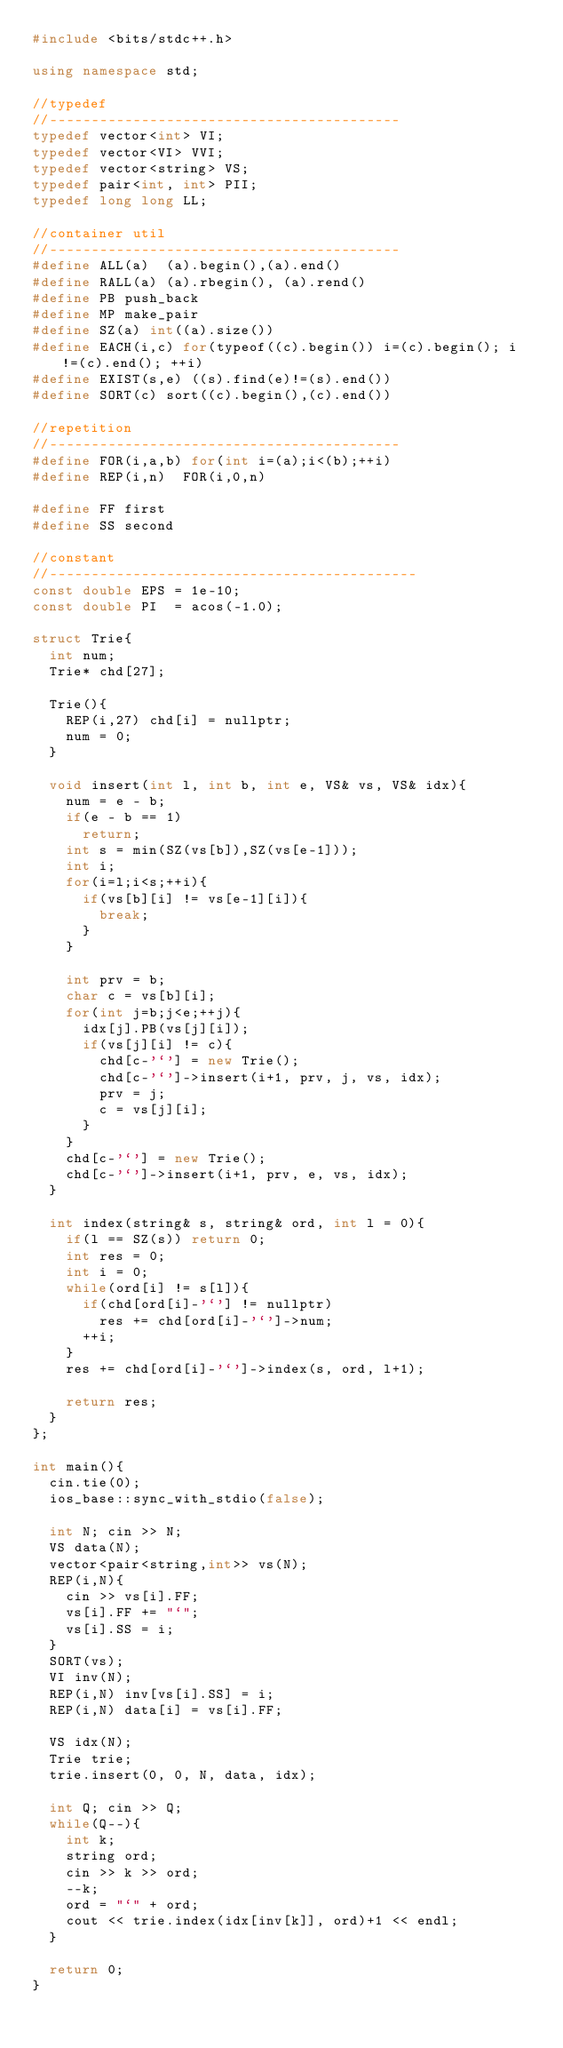Convert code to text. <code><loc_0><loc_0><loc_500><loc_500><_C++_>#include <bits/stdc++.h>
 
using namespace std;
 
//typedef
//------------------------------------------
typedef vector<int> VI;
typedef vector<VI> VVI;
typedef vector<string> VS;
typedef pair<int, int> PII;
typedef long long LL;
 
//container util
//------------------------------------------
#define ALL(a)  (a).begin(),(a).end()
#define RALL(a) (a).rbegin(), (a).rend()
#define PB push_back
#define MP make_pair
#define SZ(a) int((a).size())
#define EACH(i,c) for(typeof((c).begin()) i=(c).begin(); i!=(c).end(); ++i)
#define EXIST(s,e) ((s).find(e)!=(s).end())
#define SORT(c) sort((c).begin(),(c).end())
 
//repetition
//------------------------------------------
#define FOR(i,a,b) for(int i=(a);i<(b);++i)
#define REP(i,n)  FOR(i,0,n)

#define FF first
#define SS second
 
//constant
//--------------------------------------------
const double EPS = 1e-10;
const double PI  = acos(-1.0);

struct Trie{
  int num;
  Trie* chd[27];

  Trie(){
	REP(i,27) chd[i] = nullptr;
	num = 0;
  }

  void insert(int l, int b, int e, VS& vs, VS& idx){
	num = e - b;
	if(e - b == 1)
	  return;
	int s = min(SZ(vs[b]),SZ(vs[e-1]));
	int i;
	for(i=l;i<s;++i){
	  if(vs[b][i] != vs[e-1][i]){
		break;
	  }
	}

	int prv = b;
	char c = vs[b][i];
	for(int j=b;j<e;++j){
	  idx[j].PB(vs[j][i]);
	  if(vs[j][i] != c){
		chd[c-'`'] = new Trie();
		chd[c-'`']->insert(i+1, prv, j, vs, idx);
		prv = j;
		c = vs[j][i];
	  }
	}
	chd[c-'`'] = new Trie();
	chd[c-'`']->insert(i+1, prv, e, vs, idx);
  }

  int index(string& s, string& ord, int l = 0){
	if(l == SZ(s)) return 0;
	int res = 0;
	int i = 0;
	while(ord[i] != s[l]){
	  if(chd[ord[i]-'`'] != nullptr)
		res += chd[ord[i]-'`']->num;
	  ++i;
	}
	res += chd[ord[i]-'`']->index(s, ord, l+1);

	return res;
  }
};

int main(){
  cin.tie(0);
  ios_base::sync_with_stdio(false);

  int N; cin >> N;
  VS data(N);
  vector<pair<string,int>> vs(N);
  REP(i,N){
	cin >> vs[i].FF;
	vs[i].FF += "`";
	vs[i].SS = i;
  }
  SORT(vs);
  VI inv(N);
  REP(i,N) inv[vs[i].SS] = i;
  REP(i,N) data[i] = vs[i].FF;

  VS idx(N);
  Trie trie;
  trie.insert(0, 0, N, data, idx);

  int Q; cin >> Q;
  while(Q--){
	int k;
	string ord;
	cin >> k >> ord;
	--k;
	ord = "`" + ord;
	cout << trie.index(idx[inv[k]], ord)+1 << endl;
  }
  
  return 0;
}
</code> 